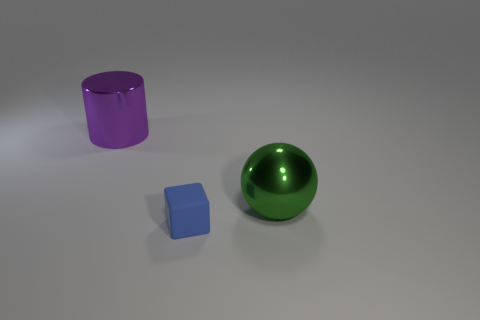Add 1 balls. How many objects exist? 4 Subtract all large brown metallic cylinders. Subtract all big metal objects. How many objects are left? 1 Add 2 purple objects. How many purple objects are left? 3 Add 2 large purple objects. How many large purple objects exist? 3 Subtract 0 red cylinders. How many objects are left? 3 Subtract all spheres. How many objects are left? 2 Subtract 1 blocks. How many blocks are left? 0 Subtract all brown blocks. Subtract all purple cylinders. How many blocks are left? 1 